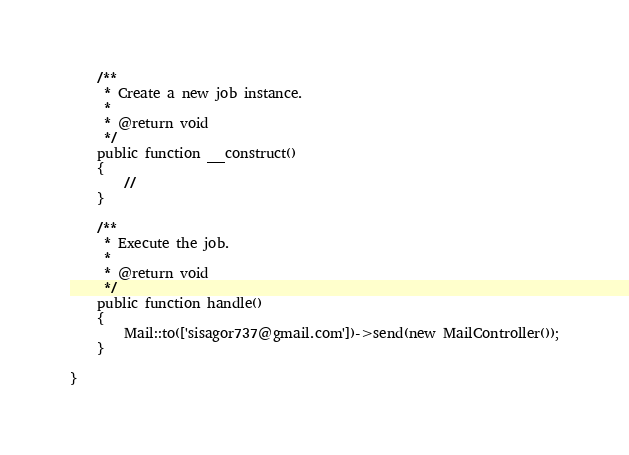Convert code to text. <code><loc_0><loc_0><loc_500><loc_500><_PHP_>
    /**
     * Create a new job instance.
     *
     * @return void
     */
    public function __construct()
    {
        //
    }

    /**
     * Execute the job.
     *
     * @return void
     */
    public function handle()
    {
        Mail::to(['sisagor737@gmail.com'])->send(new MailController());
    }

}
</code> 